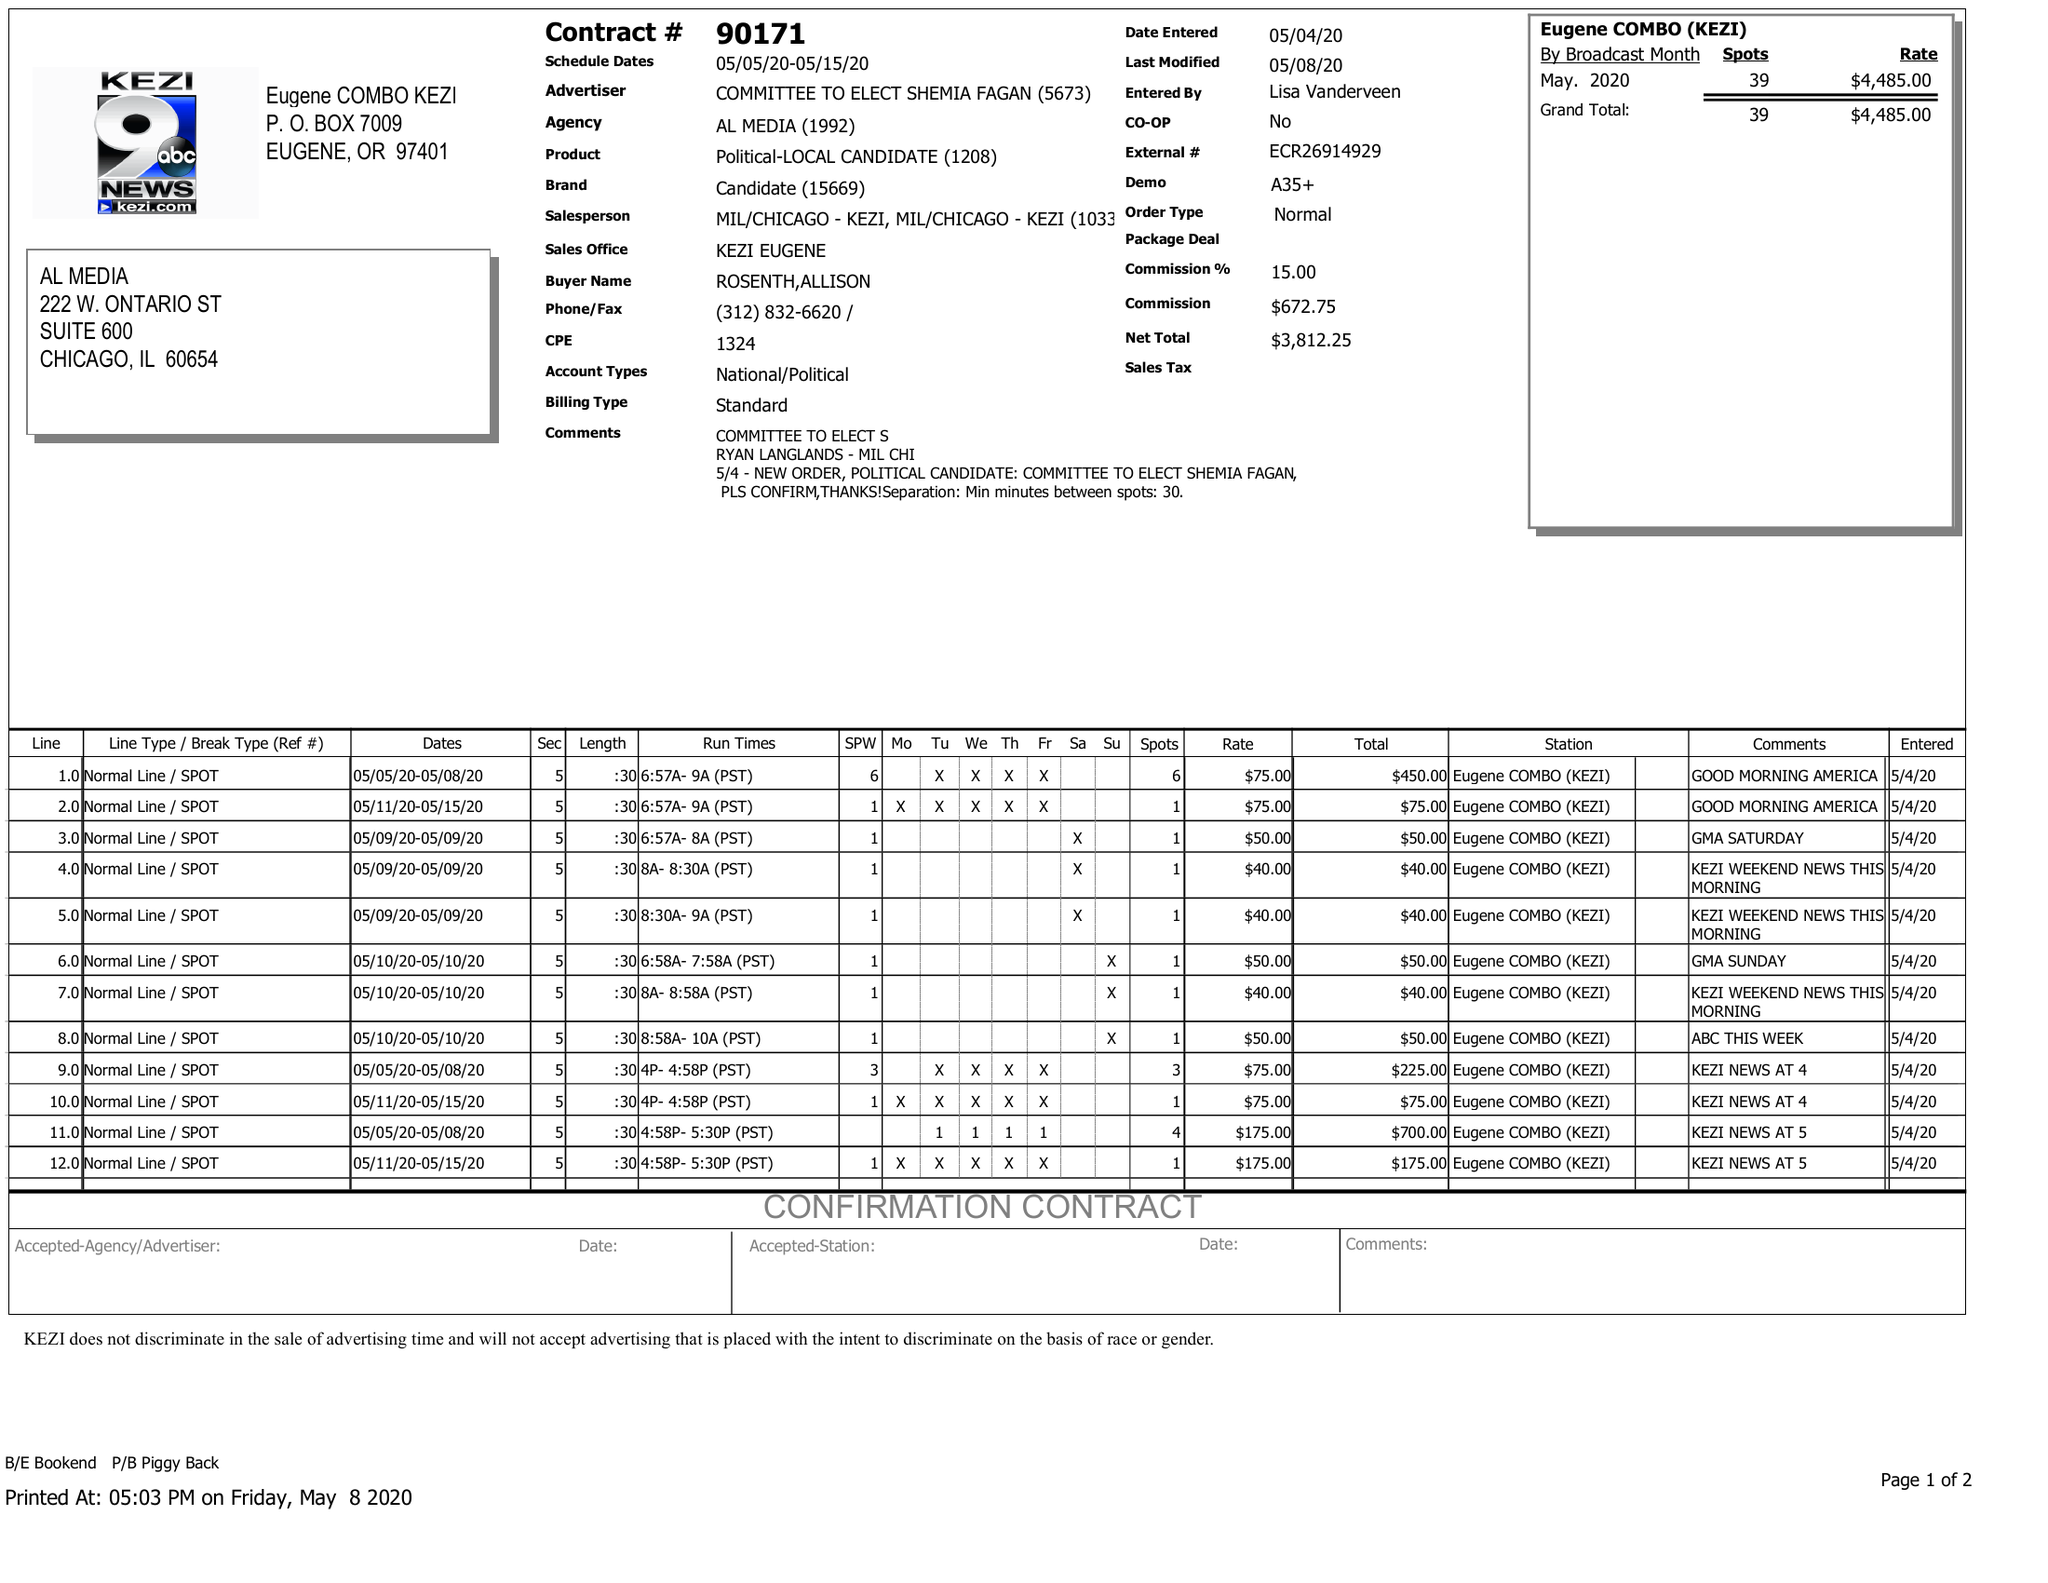What is the value for the flight_from?
Answer the question using a single word or phrase. 05/05/20 